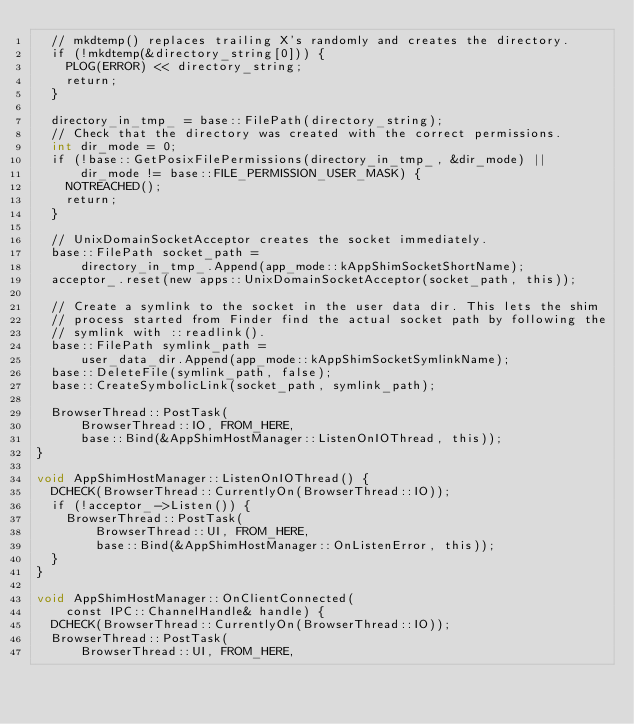Convert code to text. <code><loc_0><loc_0><loc_500><loc_500><_ObjectiveC_>  // mkdtemp() replaces trailing X's randomly and creates the directory.
  if (!mkdtemp(&directory_string[0])) {
    PLOG(ERROR) << directory_string;
    return;
  }

  directory_in_tmp_ = base::FilePath(directory_string);
  // Check that the directory was created with the correct permissions.
  int dir_mode = 0;
  if (!base::GetPosixFilePermissions(directory_in_tmp_, &dir_mode) ||
      dir_mode != base::FILE_PERMISSION_USER_MASK) {
    NOTREACHED();
    return;
  }

  // UnixDomainSocketAcceptor creates the socket immediately.
  base::FilePath socket_path =
      directory_in_tmp_.Append(app_mode::kAppShimSocketShortName);
  acceptor_.reset(new apps::UnixDomainSocketAcceptor(socket_path, this));

  // Create a symlink to the socket in the user data dir. This lets the shim
  // process started from Finder find the actual socket path by following the
  // symlink with ::readlink().
  base::FilePath symlink_path =
      user_data_dir.Append(app_mode::kAppShimSocketSymlinkName);
  base::DeleteFile(symlink_path, false);
  base::CreateSymbolicLink(socket_path, symlink_path);

  BrowserThread::PostTask(
      BrowserThread::IO, FROM_HERE,
      base::Bind(&AppShimHostManager::ListenOnIOThread, this));
}

void AppShimHostManager::ListenOnIOThread() {
  DCHECK(BrowserThread::CurrentlyOn(BrowserThread::IO));
  if (!acceptor_->Listen()) {
    BrowserThread::PostTask(
        BrowserThread::UI, FROM_HERE,
        base::Bind(&AppShimHostManager::OnListenError, this));
  }
}

void AppShimHostManager::OnClientConnected(
    const IPC::ChannelHandle& handle) {
  DCHECK(BrowserThread::CurrentlyOn(BrowserThread::IO));
  BrowserThread::PostTask(
      BrowserThread::UI, FROM_HERE,</code> 